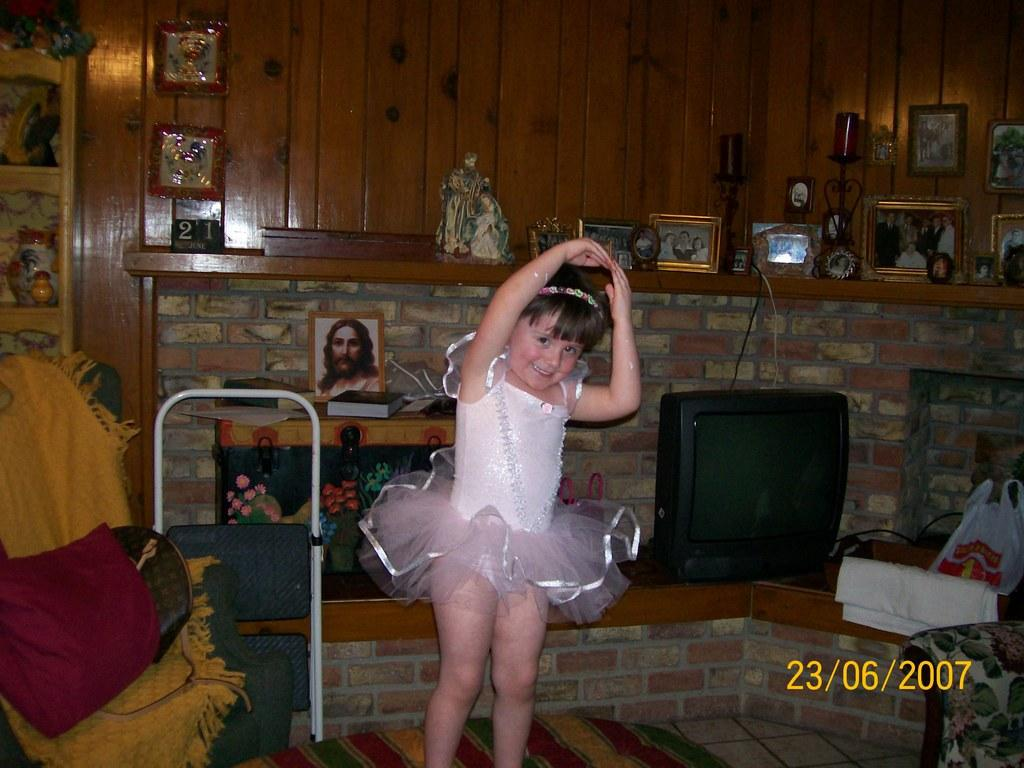Who is present in the image? There is a girl in the image. What is the girl doing in the image? The girl is smiling in the image. What piece of furniture is in the image? There is a chair in the image. What type of clothing can be seen in the image? Clothes are present in the image. What electronic device is in the image? There is a television in the image. What is covering the television in the image? A plastic cover is visible in the image. What reading material is in the image? There is a book in the image. What type of decorative items are in the image? Frames are present in the image. Are there any other objects in the image? Yes, there are other objects in the image. What can be seen in the background of the image? There is a wall in the background of the image. How many shoes are visible in the image? There are no shoes visible in the image. What type of dolls are present in the image? There are no dolls present in the image. 